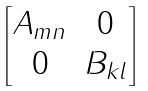<formula> <loc_0><loc_0><loc_500><loc_500>\begin{bmatrix} A _ { m n } & 0 \\ 0 & B _ { k l } \end{bmatrix}</formula> 